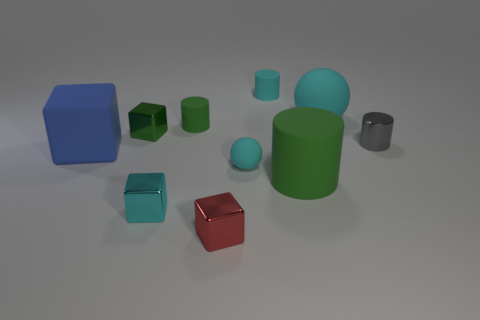There is a cylinder that is the same color as the big matte ball; what size is it?
Give a very brief answer. Small. Is the cyan metallic block the same size as the cyan matte cylinder?
Make the answer very short. Yes. What shape is the tiny gray thing that is made of the same material as the tiny green block?
Give a very brief answer. Cylinder. How many other things are there of the same shape as the large cyan object?
Keep it short and to the point. 1. There is a small cyan rubber object in front of the small green object that is behind the shiny block behind the large blue rubber object; what is its shape?
Make the answer very short. Sphere. What number of cubes are small green things or shiny things?
Make the answer very short. 3. There is a tiny matte thing that is on the left side of the small cyan sphere; is there a red metal object behind it?
Give a very brief answer. No. Does the red thing have the same shape as the large thing that is in front of the big blue block?
Your answer should be very brief. No. How many other things are the same size as the green block?
Your response must be concise. 6. How many green things are cubes or large spheres?
Offer a terse response. 1. 